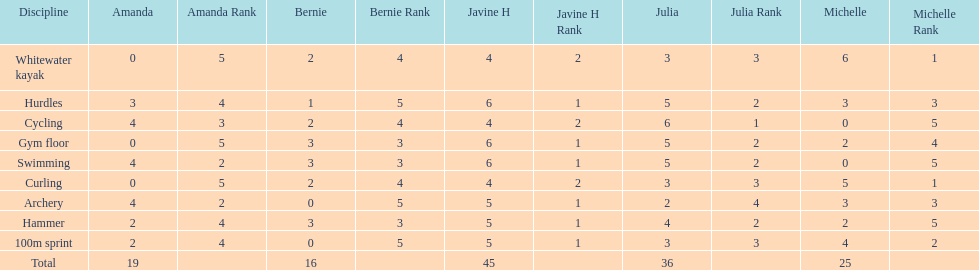Name a girl that had the same score in cycling and archery. Amanda. Could you parse the entire table? {'header': ['Discipline', 'Amanda', 'Amanda Rank', 'Bernie', 'Bernie Rank', 'Javine H', 'Javine H Rank', 'Julia', 'Julia Rank', 'Michelle', 'Michelle Rank'], 'rows': [['Whitewater kayak', '0', '5', '2', '4', '4', '2', '3', '3', '6', '1'], ['Hurdles', '3', '4', '1', '5', '6', '1', '5', '2', '3', '3'], ['Cycling', '4', '3', '2', '4', '4', '2', '6', '1', '0', '5'], ['Gym floor', '0', '5', '3', '3', '6', '1', '5', '2', '2', '4'], ['Swimming', '4', '2', '3', '3', '6', '1', '5', '2', '0', '5'], ['Curling', '0', '5', '2', '4', '4', '2', '3', '3', '5', '1'], ['Archery', '4', '2', '0', '5', '5', '1', '2', '4', '3', '3'], ['Hammer', '2', '4', '3', '3', '5', '1', '4', '2', '2', '5'], ['100m sprint', '2', '4', '0', '5', '5', '1', '3', '3', '4', '2'], ['Total', '19', '', '16', '', '45', '', '36', '', '25', '']]} 